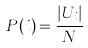Convert formula to latex. <formula><loc_0><loc_0><loc_500><loc_500>P ( i ) = \frac { | U _ { i } | } { N }</formula> 